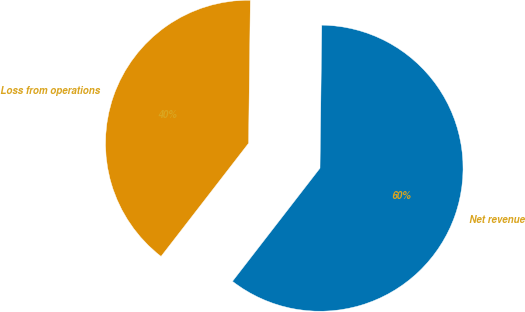<chart> <loc_0><loc_0><loc_500><loc_500><pie_chart><fcel>Net revenue<fcel>Loss from operations<nl><fcel>60.28%<fcel>39.72%<nl></chart> 